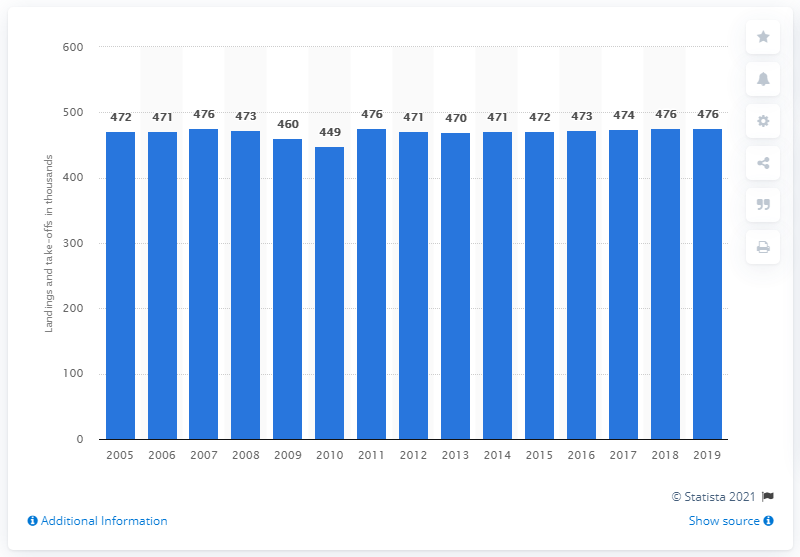Draw attention to some important aspects in this diagram. In 2005, the number of aircraft landings and take-offs at Heathrow Airport began. 